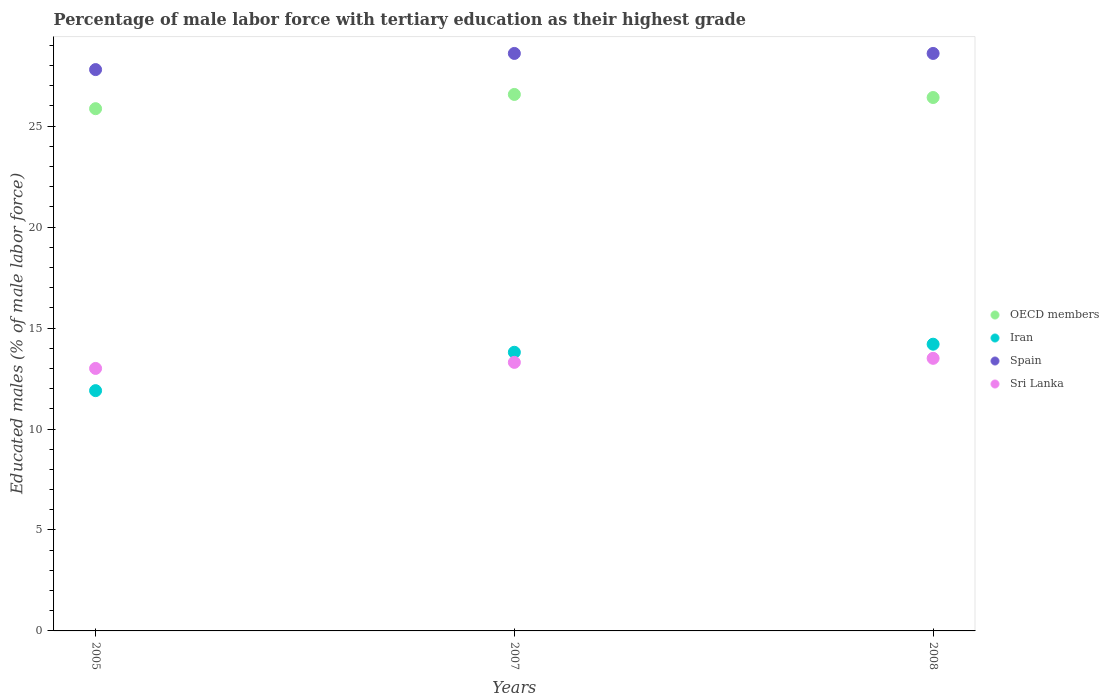What is the percentage of male labor force with tertiary education in Sri Lanka in 2007?
Provide a succinct answer. 13.3. Across all years, what is the maximum percentage of male labor force with tertiary education in Spain?
Provide a succinct answer. 28.6. Across all years, what is the minimum percentage of male labor force with tertiary education in OECD members?
Ensure brevity in your answer.  25.86. In which year was the percentage of male labor force with tertiary education in OECD members maximum?
Your answer should be very brief. 2007. In which year was the percentage of male labor force with tertiary education in Sri Lanka minimum?
Your response must be concise. 2005. What is the total percentage of male labor force with tertiary education in Spain in the graph?
Your answer should be very brief. 85. What is the difference between the percentage of male labor force with tertiary education in Spain in 2005 and that in 2007?
Offer a terse response. -0.8. What is the difference between the percentage of male labor force with tertiary education in Spain in 2005 and the percentage of male labor force with tertiary education in Iran in 2007?
Your answer should be compact. 14. What is the average percentage of male labor force with tertiary education in Sri Lanka per year?
Offer a terse response. 13.27. In the year 2007, what is the difference between the percentage of male labor force with tertiary education in OECD members and percentage of male labor force with tertiary education in Iran?
Give a very brief answer. 12.77. In how many years, is the percentage of male labor force with tertiary education in OECD members greater than 14 %?
Ensure brevity in your answer.  3. What is the ratio of the percentage of male labor force with tertiary education in Sri Lanka in 2005 to that in 2008?
Offer a terse response. 0.96. What is the difference between the highest and the second highest percentage of male labor force with tertiary education in OECD members?
Make the answer very short. 0.15. What is the difference between the highest and the lowest percentage of male labor force with tertiary education in OECD members?
Your answer should be compact. 0.71. In how many years, is the percentage of male labor force with tertiary education in OECD members greater than the average percentage of male labor force with tertiary education in OECD members taken over all years?
Offer a terse response. 2. Is the percentage of male labor force with tertiary education in Spain strictly greater than the percentage of male labor force with tertiary education in Sri Lanka over the years?
Keep it short and to the point. Yes. How many years are there in the graph?
Give a very brief answer. 3. Are the values on the major ticks of Y-axis written in scientific E-notation?
Your response must be concise. No. Does the graph contain any zero values?
Your answer should be very brief. No. Where does the legend appear in the graph?
Offer a terse response. Center right. How are the legend labels stacked?
Provide a short and direct response. Vertical. What is the title of the graph?
Give a very brief answer. Percentage of male labor force with tertiary education as their highest grade. What is the label or title of the X-axis?
Ensure brevity in your answer.  Years. What is the label or title of the Y-axis?
Offer a very short reply. Educated males (% of male labor force). What is the Educated males (% of male labor force) of OECD members in 2005?
Make the answer very short. 25.86. What is the Educated males (% of male labor force) in Iran in 2005?
Provide a succinct answer. 11.9. What is the Educated males (% of male labor force) of Spain in 2005?
Your response must be concise. 27.8. What is the Educated males (% of male labor force) of OECD members in 2007?
Offer a very short reply. 26.57. What is the Educated males (% of male labor force) in Iran in 2007?
Your answer should be compact. 13.8. What is the Educated males (% of male labor force) of Spain in 2007?
Provide a short and direct response. 28.6. What is the Educated males (% of male labor force) of Sri Lanka in 2007?
Offer a very short reply. 13.3. What is the Educated males (% of male labor force) of OECD members in 2008?
Your response must be concise. 26.42. What is the Educated males (% of male labor force) of Iran in 2008?
Keep it short and to the point. 14.2. What is the Educated males (% of male labor force) of Spain in 2008?
Ensure brevity in your answer.  28.6. Across all years, what is the maximum Educated males (% of male labor force) of OECD members?
Your response must be concise. 26.57. Across all years, what is the maximum Educated males (% of male labor force) of Iran?
Ensure brevity in your answer.  14.2. Across all years, what is the maximum Educated males (% of male labor force) in Spain?
Give a very brief answer. 28.6. Across all years, what is the minimum Educated males (% of male labor force) of OECD members?
Make the answer very short. 25.86. Across all years, what is the minimum Educated males (% of male labor force) in Iran?
Your answer should be compact. 11.9. Across all years, what is the minimum Educated males (% of male labor force) of Spain?
Your response must be concise. 27.8. Across all years, what is the minimum Educated males (% of male labor force) in Sri Lanka?
Offer a terse response. 13. What is the total Educated males (% of male labor force) in OECD members in the graph?
Your answer should be compact. 78.85. What is the total Educated males (% of male labor force) of Iran in the graph?
Ensure brevity in your answer.  39.9. What is the total Educated males (% of male labor force) in Spain in the graph?
Provide a succinct answer. 85. What is the total Educated males (% of male labor force) of Sri Lanka in the graph?
Make the answer very short. 39.8. What is the difference between the Educated males (% of male labor force) in OECD members in 2005 and that in 2007?
Offer a very short reply. -0.71. What is the difference between the Educated males (% of male labor force) in Iran in 2005 and that in 2007?
Your answer should be compact. -1.9. What is the difference between the Educated males (% of male labor force) in Spain in 2005 and that in 2007?
Your answer should be very brief. -0.8. What is the difference between the Educated males (% of male labor force) of OECD members in 2005 and that in 2008?
Your response must be concise. -0.55. What is the difference between the Educated males (% of male labor force) of OECD members in 2007 and that in 2008?
Provide a succinct answer. 0.15. What is the difference between the Educated males (% of male labor force) of OECD members in 2005 and the Educated males (% of male labor force) of Iran in 2007?
Your response must be concise. 12.06. What is the difference between the Educated males (% of male labor force) in OECD members in 2005 and the Educated males (% of male labor force) in Spain in 2007?
Provide a succinct answer. -2.74. What is the difference between the Educated males (% of male labor force) of OECD members in 2005 and the Educated males (% of male labor force) of Sri Lanka in 2007?
Your answer should be compact. 12.56. What is the difference between the Educated males (% of male labor force) in Iran in 2005 and the Educated males (% of male labor force) in Spain in 2007?
Your response must be concise. -16.7. What is the difference between the Educated males (% of male labor force) of Iran in 2005 and the Educated males (% of male labor force) of Sri Lanka in 2007?
Your answer should be very brief. -1.4. What is the difference between the Educated males (% of male labor force) in Spain in 2005 and the Educated males (% of male labor force) in Sri Lanka in 2007?
Offer a terse response. 14.5. What is the difference between the Educated males (% of male labor force) of OECD members in 2005 and the Educated males (% of male labor force) of Iran in 2008?
Offer a very short reply. 11.66. What is the difference between the Educated males (% of male labor force) in OECD members in 2005 and the Educated males (% of male labor force) in Spain in 2008?
Make the answer very short. -2.74. What is the difference between the Educated males (% of male labor force) of OECD members in 2005 and the Educated males (% of male labor force) of Sri Lanka in 2008?
Offer a terse response. 12.36. What is the difference between the Educated males (% of male labor force) of Iran in 2005 and the Educated males (% of male labor force) of Spain in 2008?
Your answer should be compact. -16.7. What is the difference between the Educated males (% of male labor force) of Spain in 2005 and the Educated males (% of male labor force) of Sri Lanka in 2008?
Your response must be concise. 14.3. What is the difference between the Educated males (% of male labor force) in OECD members in 2007 and the Educated males (% of male labor force) in Iran in 2008?
Your answer should be very brief. 12.37. What is the difference between the Educated males (% of male labor force) of OECD members in 2007 and the Educated males (% of male labor force) of Spain in 2008?
Make the answer very short. -2.03. What is the difference between the Educated males (% of male labor force) of OECD members in 2007 and the Educated males (% of male labor force) of Sri Lanka in 2008?
Give a very brief answer. 13.07. What is the difference between the Educated males (% of male labor force) of Iran in 2007 and the Educated males (% of male labor force) of Spain in 2008?
Your answer should be compact. -14.8. What is the difference between the Educated males (% of male labor force) in Iran in 2007 and the Educated males (% of male labor force) in Sri Lanka in 2008?
Your answer should be compact. 0.3. What is the average Educated males (% of male labor force) in OECD members per year?
Offer a very short reply. 26.28. What is the average Educated males (% of male labor force) in Iran per year?
Keep it short and to the point. 13.3. What is the average Educated males (% of male labor force) of Spain per year?
Provide a succinct answer. 28.33. What is the average Educated males (% of male labor force) of Sri Lanka per year?
Offer a very short reply. 13.27. In the year 2005, what is the difference between the Educated males (% of male labor force) of OECD members and Educated males (% of male labor force) of Iran?
Provide a short and direct response. 13.96. In the year 2005, what is the difference between the Educated males (% of male labor force) in OECD members and Educated males (% of male labor force) in Spain?
Make the answer very short. -1.94. In the year 2005, what is the difference between the Educated males (% of male labor force) of OECD members and Educated males (% of male labor force) of Sri Lanka?
Provide a short and direct response. 12.86. In the year 2005, what is the difference between the Educated males (% of male labor force) in Iran and Educated males (% of male labor force) in Spain?
Offer a very short reply. -15.9. In the year 2005, what is the difference between the Educated males (% of male labor force) in Iran and Educated males (% of male labor force) in Sri Lanka?
Your response must be concise. -1.1. In the year 2005, what is the difference between the Educated males (% of male labor force) of Spain and Educated males (% of male labor force) of Sri Lanka?
Provide a short and direct response. 14.8. In the year 2007, what is the difference between the Educated males (% of male labor force) in OECD members and Educated males (% of male labor force) in Iran?
Provide a succinct answer. 12.77. In the year 2007, what is the difference between the Educated males (% of male labor force) in OECD members and Educated males (% of male labor force) in Spain?
Ensure brevity in your answer.  -2.03. In the year 2007, what is the difference between the Educated males (% of male labor force) in OECD members and Educated males (% of male labor force) in Sri Lanka?
Your response must be concise. 13.27. In the year 2007, what is the difference between the Educated males (% of male labor force) of Iran and Educated males (% of male labor force) of Spain?
Offer a very short reply. -14.8. In the year 2007, what is the difference between the Educated males (% of male labor force) of Iran and Educated males (% of male labor force) of Sri Lanka?
Your response must be concise. 0.5. In the year 2008, what is the difference between the Educated males (% of male labor force) in OECD members and Educated males (% of male labor force) in Iran?
Offer a very short reply. 12.22. In the year 2008, what is the difference between the Educated males (% of male labor force) in OECD members and Educated males (% of male labor force) in Spain?
Provide a succinct answer. -2.18. In the year 2008, what is the difference between the Educated males (% of male labor force) of OECD members and Educated males (% of male labor force) of Sri Lanka?
Offer a very short reply. 12.92. In the year 2008, what is the difference between the Educated males (% of male labor force) of Iran and Educated males (% of male labor force) of Spain?
Keep it short and to the point. -14.4. What is the ratio of the Educated males (% of male labor force) in OECD members in 2005 to that in 2007?
Make the answer very short. 0.97. What is the ratio of the Educated males (% of male labor force) in Iran in 2005 to that in 2007?
Your answer should be very brief. 0.86. What is the ratio of the Educated males (% of male labor force) of Spain in 2005 to that in 2007?
Provide a short and direct response. 0.97. What is the ratio of the Educated males (% of male labor force) in Sri Lanka in 2005 to that in 2007?
Give a very brief answer. 0.98. What is the ratio of the Educated males (% of male labor force) in OECD members in 2005 to that in 2008?
Give a very brief answer. 0.98. What is the ratio of the Educated males (% of male labor force) in Iran in 2005 to that in 2008?
Your answer should be very brief. 0.84. What is the ratio of the Educated males (% of male labor force) of Spain in 2005 to that in 2008?
Your response must be concise. 0.97. What is the ratio of the Educated males (% of male labor force) of Sri Lanka in 2005 to that in 2008?
Your answer should be compact. 0.96. What is the ratio of the Educated males (% of male labor force) in OECD members in 2007 to that in 2008?
Provide a succinct answer. 1.01. What is the ratio of the Educated males (% of male labor force) in Iran in 2007 to that in 2008?
Provide a succinct answer. 0.97. What is the ratio of the Educated males (% of male labor force) of Spain in 2007 to that in 2008?
Make the answer very short. 1. What is the ratio of the Educated males (% of male labor force) of Sri Lanka in 2007 to that in 2008?
Provide a succinct answer. 0.99. What is the difference between the highest and the second highest Educated males (% of male labor force) in OECD members?
Ensure brevity in your answer.  0.15. What is the difference between the highest and the second highest Educated males (% of male labor force) of Spain?
Your answer should be very brief. 0. What is the difference between the highest and the second highest Educated males (% of male labor force) in Sri Lanka?
Offer a terse response. 0.2. What is the difference between the highest and the lowest Educated males (% of male labor force) in OECD members?
Your answer should be very brief. 0.71. What is the difference between the highest and the lowest Educated males (% of male labor force) in Spain?
Your answer should be compact. 0.8. 